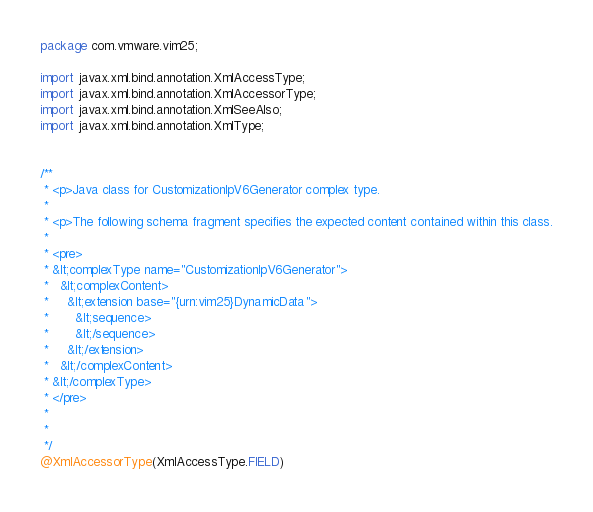<code> <loc_0><loc_0><loc_500><loc_500><_Java_>
package com.vmware.vim25;

import javax.xml.bind.annotation.XmlAccessType;
import javax.xml.bind.annotation.XmlAccessorType;
import javax.xml.bind.annotation.XmlSeeAlso;
import javax.xml.bind.annotation.XmlType;


/**
 * <p>Java class for CustomizationIpV6Generator complex type.
 * 
 * <p>The following schema fragment specifies the expected content contained within this class.
 * 
 * <pre>
 * &lt;complexType name="CustomizationIpV6Generator">
 *   &lt;complexContent>
 *     &lt;extension base="{urn:vim25}DynamicData">
 *       &lt;sequence>
 *       &lt;/sequence>
 *     &lt;/extension>
 *   &lt;/complexContent>
 * &lt;/complexType>
 * </pre>
 * 
 * 
 */
@XmlAccessorType(XmlAccessType.FIELD)</code> 